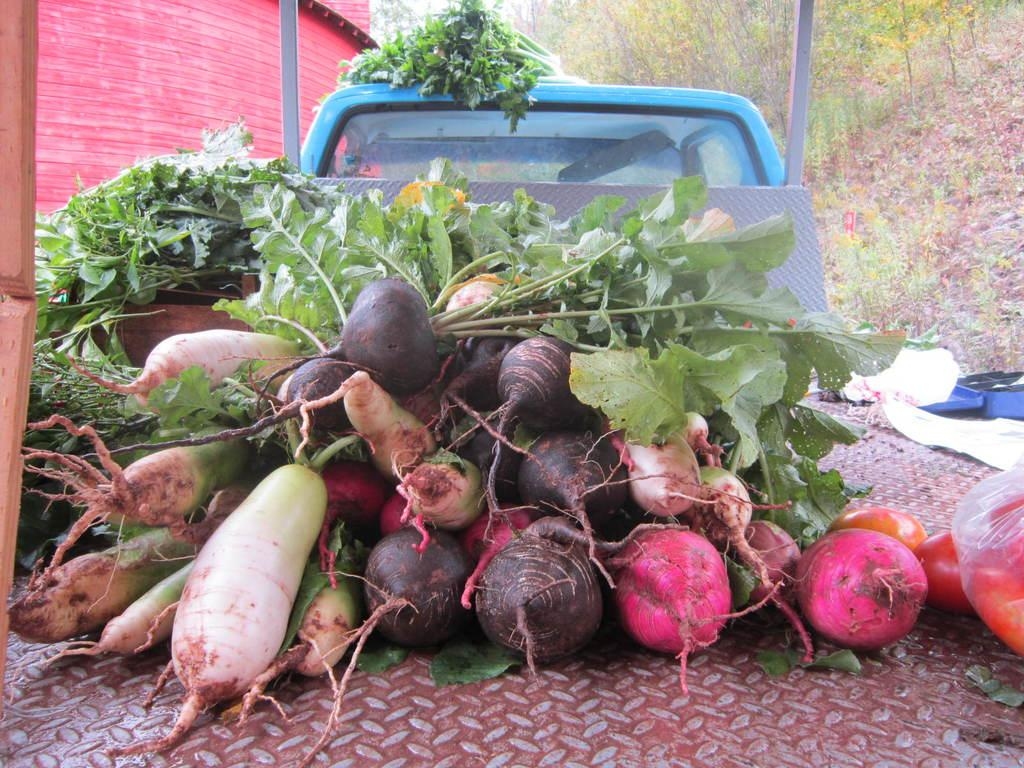What is the vehicle in the image carrying? The vehicle in the image is loaded with vegetables. What is at the bottom of the image? There is an iron sheet at the bottom of the image. What can be seen in the background of the image? There are trees, poles, and a building in the background of the image. What type of root is growing near the vehicle in the image? There is no root visible in the image; it only shows a vehicle loaded with vegetables, an iron sheet at the bottom, and background elements like trees, poles, and a building. 